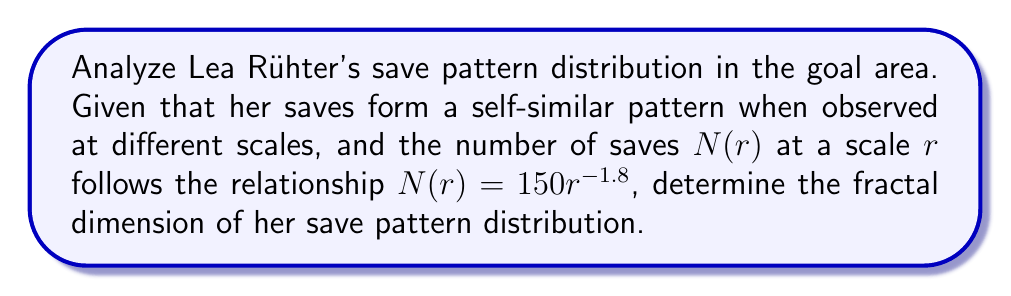Can you solve this math problem? To determine the fractal dimension of Lea Rühter's save pattern distribution, we'll follow these steps:

1. Recall the formula for fractal dimension $D$ in a self-similar set:

   $$N(r) = cr^{-D}$$

   where $N(r)$ is the number of objects at scale $r$, $c$ is a constant, and $D$ is the fractal dimension.

2. Compare the given equation to the general formula:

   $$N(r) = 150r^{-1.8}$$

3. Identify the components:
   - $c = 150$
   - The exponent $-1.8$ corresponds to $-D$

4. Therefore, we can conclude that:

   $$D = 1.8$$

5. The fractal dimension is the absolute value of the exponent in the scaling relationship.

This fractal dimension of 1.8 suggests that Lea Rühter's save pattern distribution is more complex than a simple line (dimension 1) but doesn't quite fill a plane (dimension 2). It indicates a highly intricate and space-filling pattern of saves, reflecting her exceptional skill and unpredictability as a handball goalkeeper.
Answer: $1.8$ 